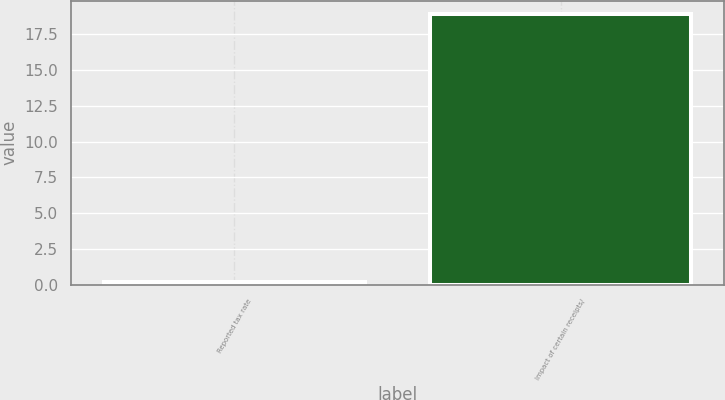Convert chart. <chart><loc_0><loc_0><loc_500><loc_500><bar_chart><fcel>Reported tax rate<fcel>Impact of certain receipts/<nl><fcel>0.2<fcel>18.9<nl></chart> 